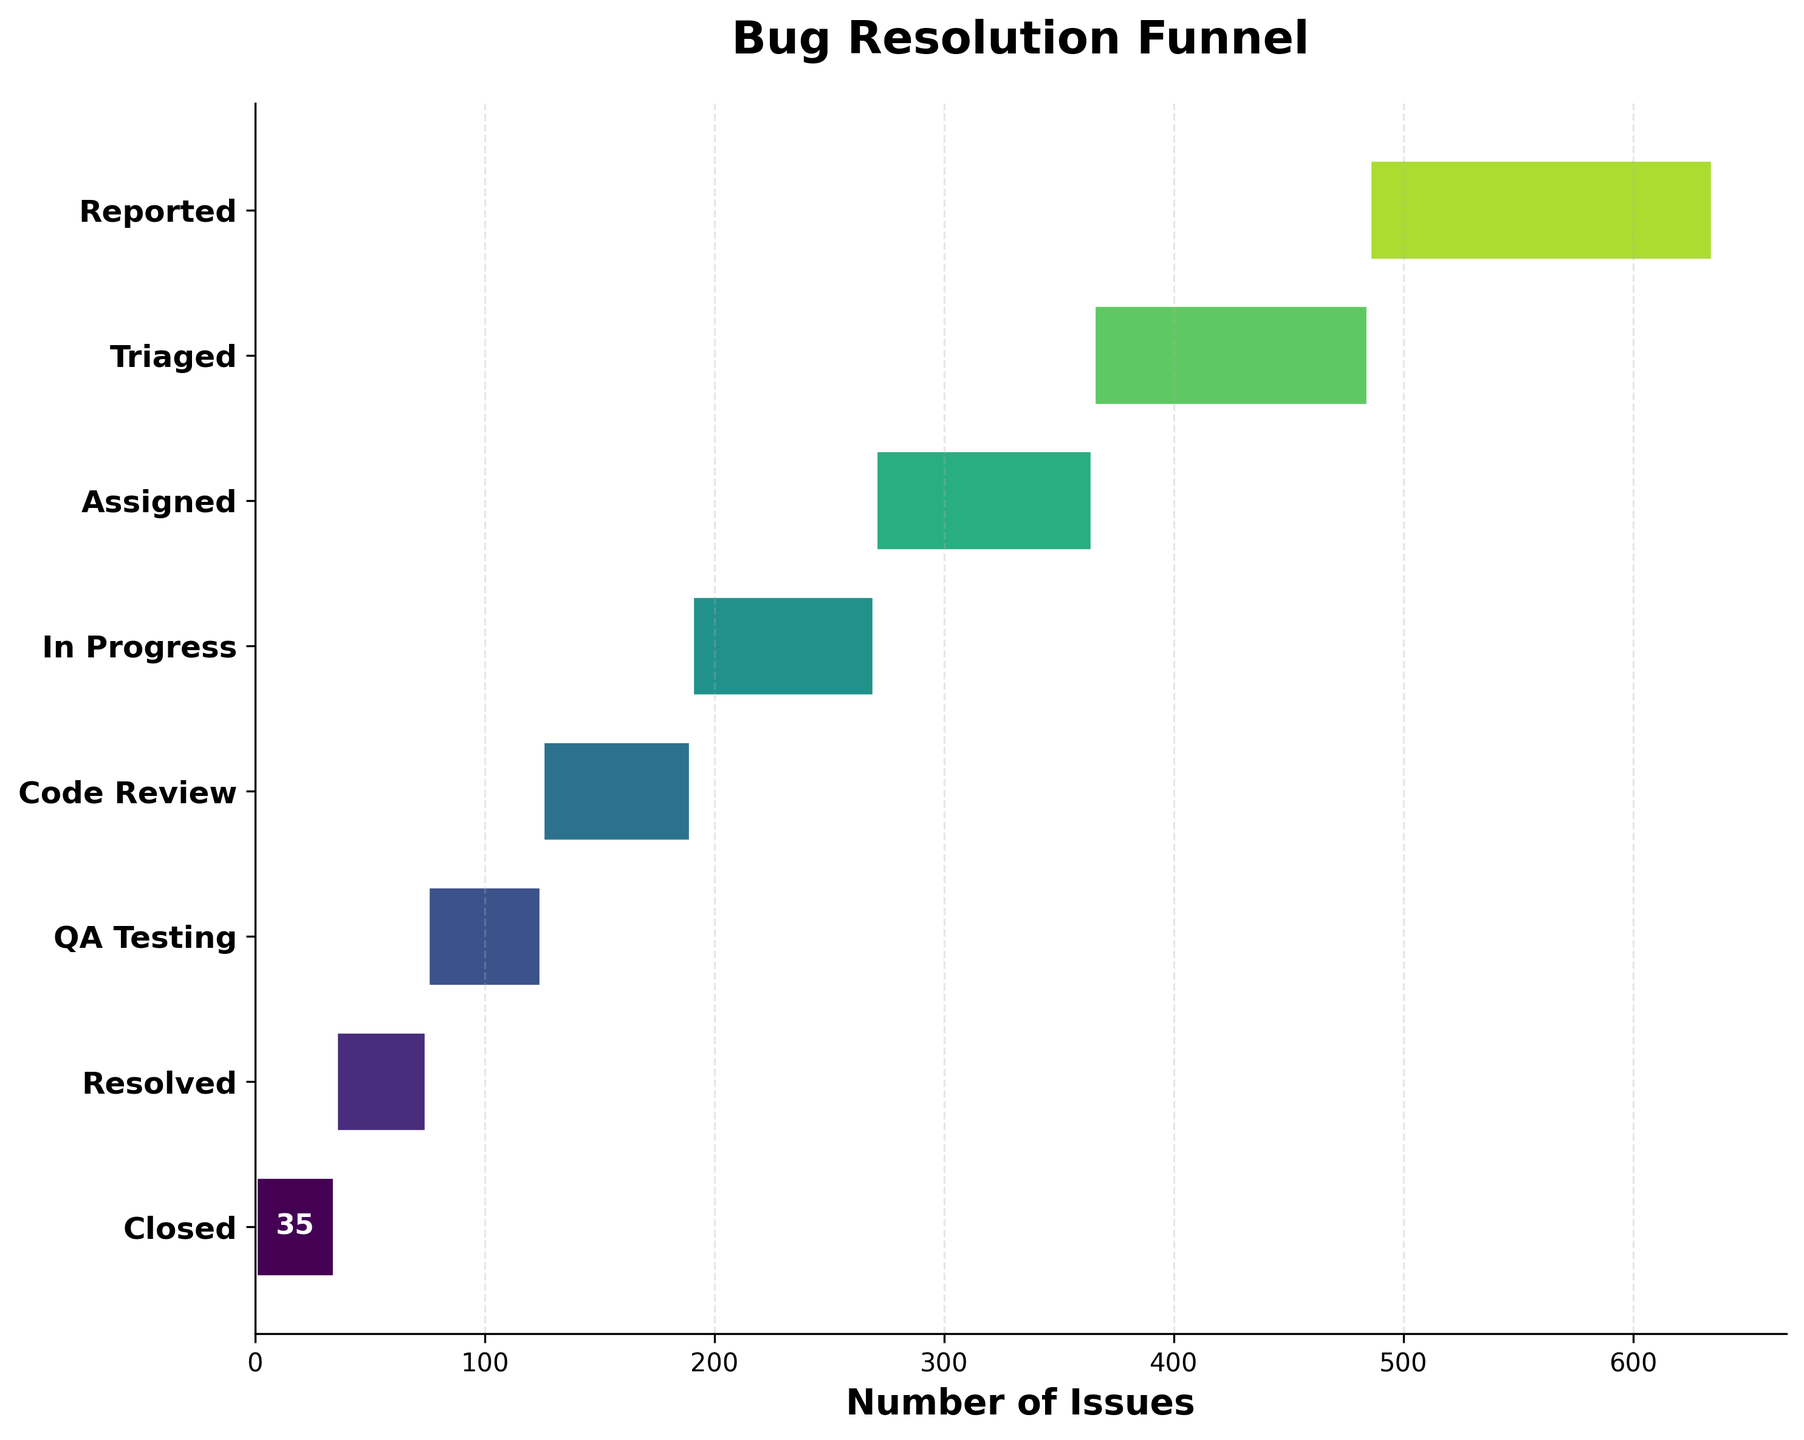What is the title of the figure? The title of the figure is displayed at the top of the chart. It provides a summary of what the chart represents.
Answer: Bug Resolution Funnel How many stages are displayed in the funnel chart? By counting the different stages listed on the vertical axis, which represent steps in the bug resolution process, you can determine how many stages are shown.
Answer: 8 What is the number of issues at the "Code Review" stage? Locate the "Code Review" stage on the vertical axis, then read the number of issues displayed within the corresponding bar.
Answer: 65 How does the number of issues change from the "Reported" stage to the "Closed" stage? Compare the number of issues at the "Reported" stage (leftmost/top bar) with the number at the "Closed" stage (rightmost/bottom bar). The difference shows how many issues were resolved through the process.
Answer: 115 fewer issues What is the difference in the number of issues between the "Assigned" and "QA Testing" stages? Subtract the number of issues at the "QA Testing" stage from the number at the "Assigned" stage.
Answer: 45 Which stage has the second highest number of issues? Identify the stages with their respective issue counts, then determine which one has the second largest count.
Answer: Triaged (120 issues) Are there more issues in the "In Progress" stage compared to the "Resolved" stage? Compare the number of issues between the "In Progress" and "Resolved" stages by checking their respective bar lengths or label values.
Answer: Yes What can you infer about the effectiveness of the bug resolution process from stage "Triaged" to stage "Closed"? Assess the reduction in the number of issues through the stages from "Triaged" to "Closed." A consistent reduction indicates that issues are being effectively resolved at each stage.
Answer: Effective What percentage of the reported issues reach the "Closed" stage? Divide the number of issues at the "Closed" stage by the number of issues at the "Reported" stage and multiply by 100 to get the percentage. (35 / 150) * 100.
Answer: 23.33% Which stage experiences the largest drop in the number of issues from the previous stage? Examine the differences in issue counts between each consecutive stage to determine which one has the largest drop.
Answer: Reported to Triaged (30 issues fewer) 